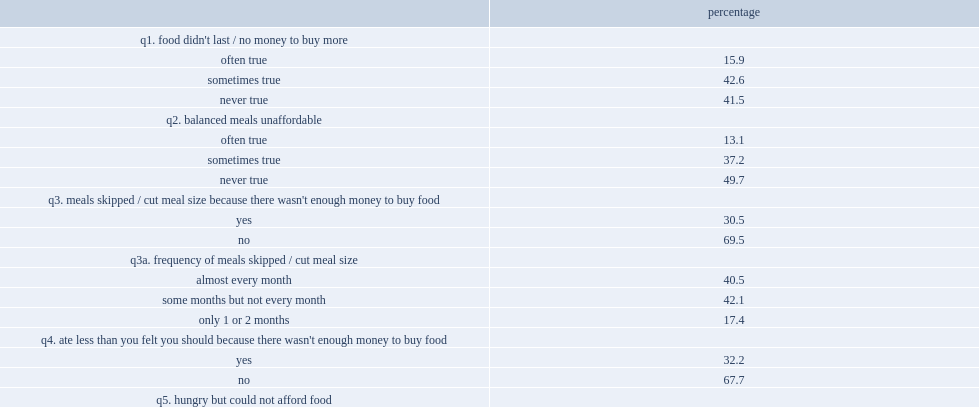In 2012, what was the percentage of inuit aged 25 and over in inuit nunangat lived in a household where it was often true that food did not last and there was no money to buy more food during the past 12 months? 15.9. In 2012, what was the percentage of inuit aged 25 and over in inuit nunangat lived in a household where it was sometimes true that food did not last and there was no money to buy more food during the past 12 months? 42.6. What was the percentage of inuit lived in a household where they or other household members cut the size of their meals or skipped meals because there was not enough money for food? 30.5. Among those who skipped meals or cut meal size, what was the percentage of doing so almost every month? 40.5. Among those who skipped meals or cut meal size, what was the percentage of skipping some months but not every month? 42.1. What was the percentage of inuit reported eating less than they should because there was not enough money to buy food? 32.2. What was the percentage of inuit reported that, in the previous 12 months, they had been hungry because they could not afford enough food? 26.8. 